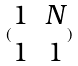<formula> <loc_0><loc_0><loc_500><loc_500>( \begin{matrix} 1 & N \\ 1 & 1 \end{matrix} )</formula> 